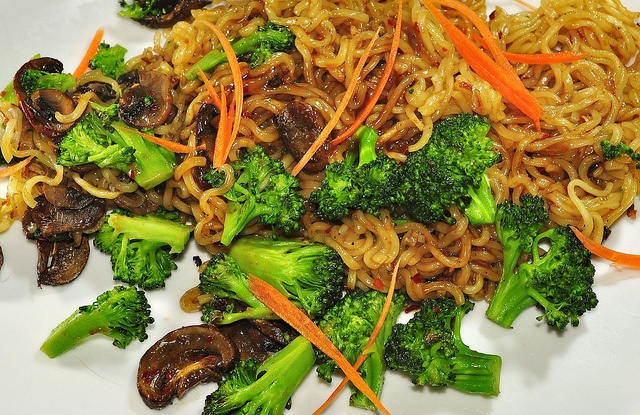Describe the objects in this image and their specific colors. I can see broccoli in lightgray, olive, black, and darkgreen tones, broccoli in lightgray, green, black, and darkgreen tones, broccoli in lightgray, darkgreen, black, and green tones, broccoli in lightgray, olive, darkgreen, and black tones, and broccoli in lightgray, black, darkgreen, and green tones in this image. 